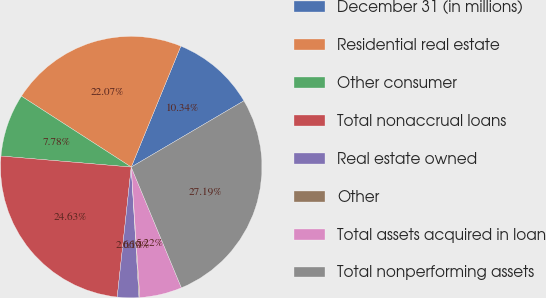Convert chart. <chart><loc_0><loc_0><loc_500><loc_500><pie_chart><fcel>December 31 (in millions)<fcel>Residential real estate<fcel>Other consumer<fcel>Total nonaccrual loans<fcel>Real estate owned<fcel>Other<fcel>Total assets acquired in loan<fcel>Total nonperforming assets<nl><fcel>10.34%<fcel>22.07%<fcel>7.78%<fcel>24.63%<fcel>2.66%<fcel>0.1%<fcel>5.22%<fcel>27.19%<nl></chart> 